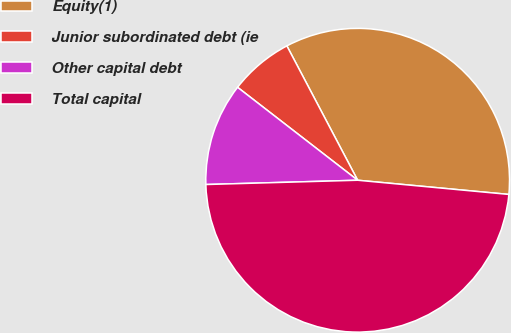Convert chart. <chart><loc_0><loc_0><loc_500><loc_500><pie_chart><fcel>Equity(1)<fcel>Junior subordinated debt (ie<fcel>Other capital debt<fcel>Total capital<nl><fcel>34.21%<fcel>6.8%<fcel>10.93%<fcel>48.06%<nl></chart> 